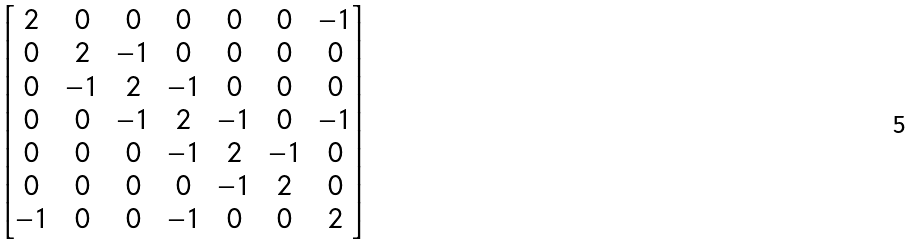<formula> <loc_0><loc_0><loc_500><loc_500>\begin{bmatrix} 2 & 0 & 0 & 0 & 0 & 0 & - 1 \\ 0 & 2 & - 1 & 0 & 0 & 0 & 0 \\ 0 & - 1 & 2 & - 1 & 0 & 0 & 0 \\ 0 & 0 & - 1 & 2 & - 1 & 0 & - 1 \\ 0 & 0 & 0 & - 1 & 2 & - 1 & 0 \\ 0 & 0 & 0 & 0 & - 1 & 2 & 0 \\ - 1 & 0 & 0 & - 1 & 0 & 0 & 2 \\ \end{bmatrix}</formula> 